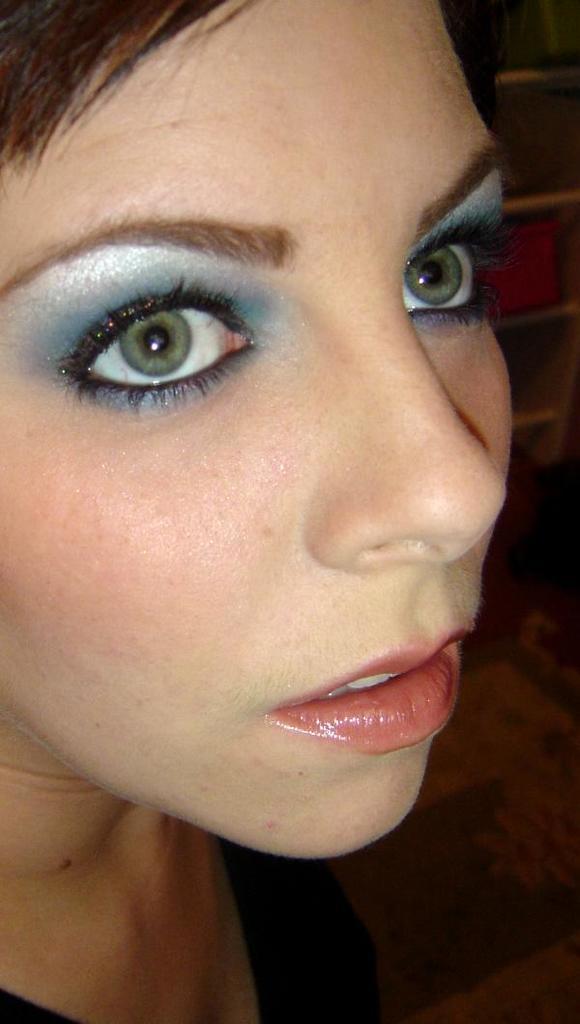In one or two sentences, can you explain what this image depicts? In this image in front there is a person. On the right side of the image there are few objects. 